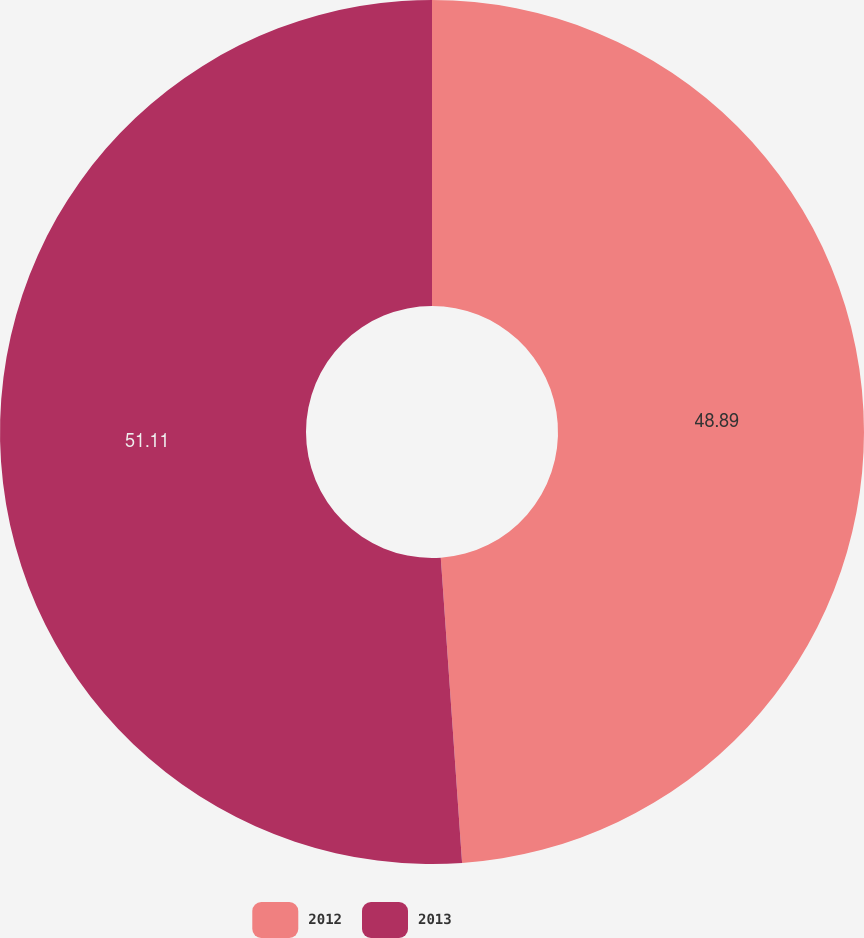<chart> <loc_0><loc_0><loc_500><loc_500><pie_chart><fcel>2012<fcel>2013<nl><fcel>48.89%<fcel>51.11%<nl></chart> 